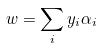Convert formula to latex. <formula><loc_0><loc_0><loc_500><loc_500>w = \sum _ { i } y _ { i } \alpha _ { i }</formula> 